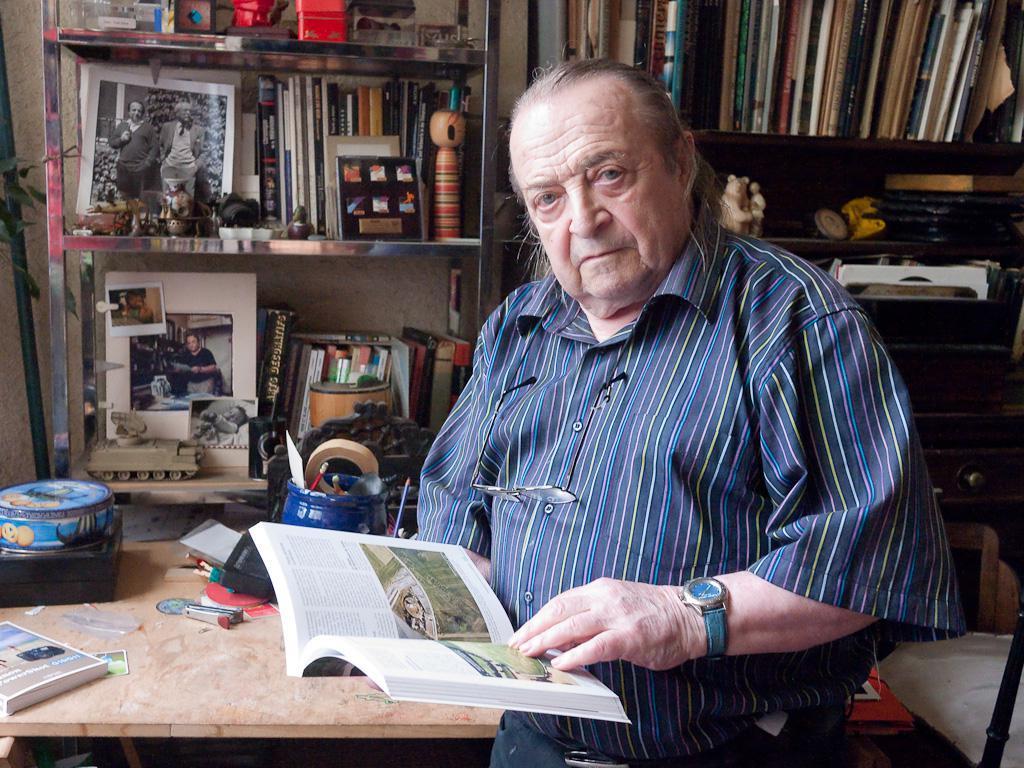Could you give a brief overview of what you see in this image? In this picture we can see a Man Standing and holding a book looking to the camera side one table is there on the table we can see one book and some boxes and back side we can see the books shelf many books are there and we can see one photo frame 